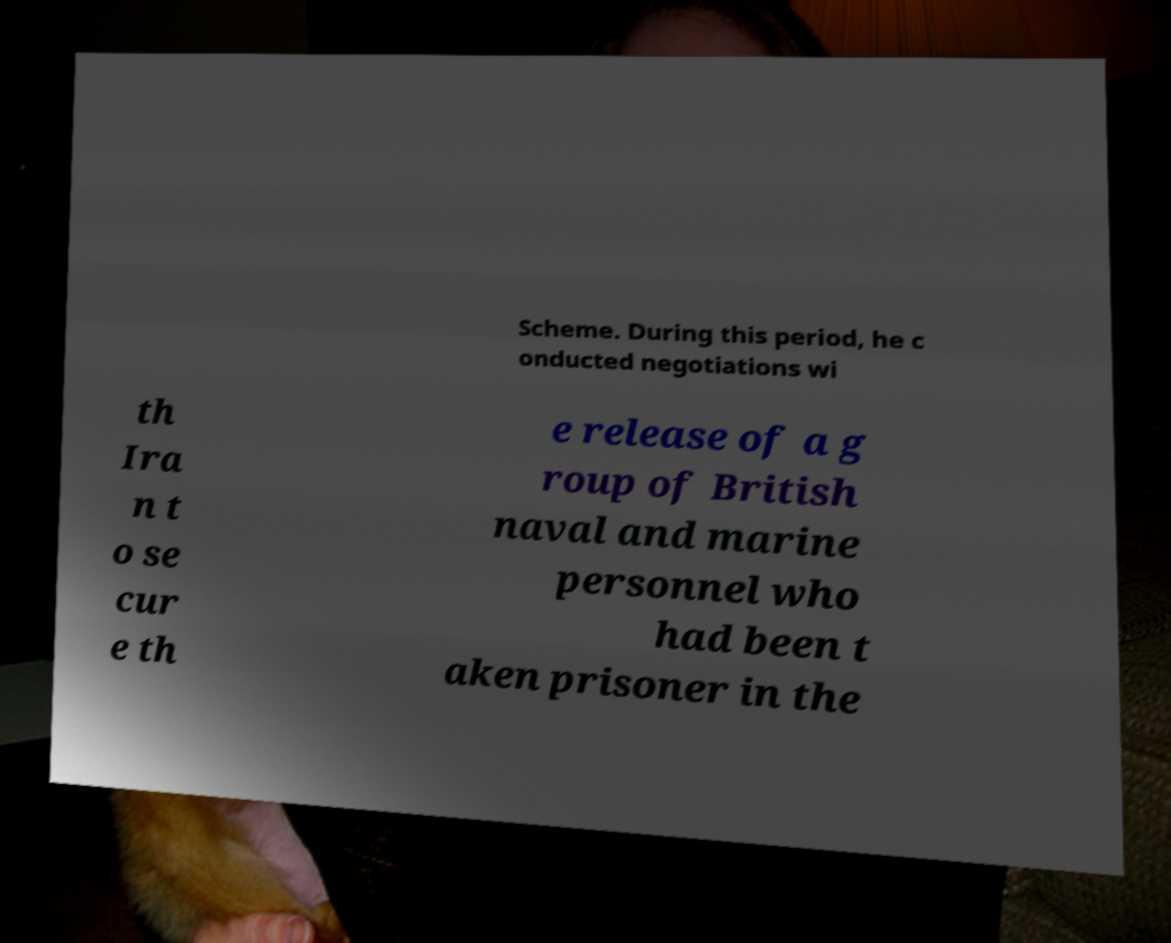Please read and relay the text visible in this image. What does it say? Scheme. During this period, he c onducted negotiations wi th Ira n t o se cur e th e release of a g roup of British naval and marine personnel who had been t aken prisoner in the 